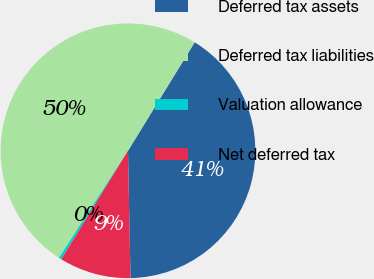Convert chart to OTSL. <chart><loc_0><loc_0><loc_500><loc_500><pie_chart><fcel>Deferred tax assets<fcel>Deferred tax liabilities<fcel>Valuation allowance<fcel>Net deferred tax<nl><fcel>40.91%<fcel>49.66%<fcel>0.34%<fcel>9.09%<nl></chart> 